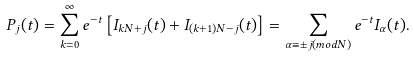<formula> <loc_0><loc_0><loc_500><loc_500>P _ { j } ( t ) = \sum _ { k = 0 } ^ { \infty } e ^ { - t } \left [ I _ { k N + j } ( t ) + I _ { ( k + 1 ) N - j } ( t ) \right ] = \sum _ { \alpha \equiv \pm j ( m o d N ) } e ^ { - t } I _ { \alpha } ( t ) .</formula> 